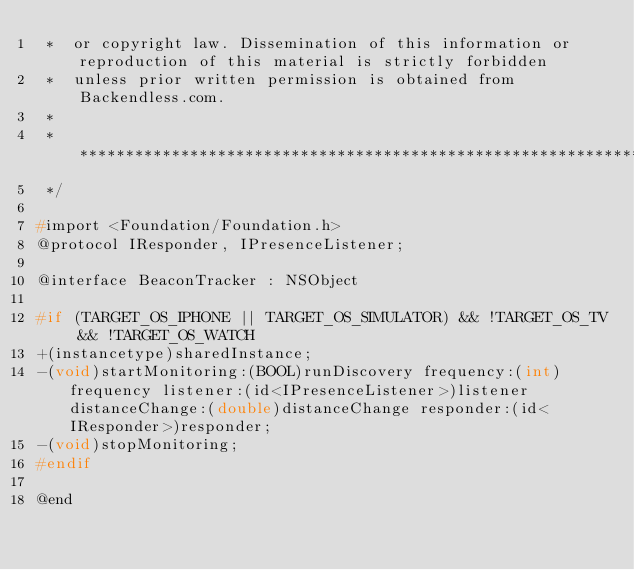<code> <loc_0><loc_0><loc_500><loc_500><_C_> *  or copyright law. Dissemination of this information or reproduction of this material is strictly forbidden
 *  unless prior written permission is obtained from Backendless.com.
 *
 *  ********************************************************************************************************************
 */

#import <Foundation/Foundation.h>
@protocol IResponder, IPresenceListener;

@interface BeaconTracker : NSObject

#if (TARGET_OS_IPHONE || TARGET_OS_SIMULATOR) && !TARGET_OS_TV && !TARGET_OS_WATCH
+(instancetype)sharedInstance;
-(void)startMonitoring:(BOOL)runDiscovery frequency:(int)frequency listener:(id<IPresenceListener>)listener distanceChange:(double)distanceChange responder:(id<IResponder>)responder;
-(void)stopMonitoring;
#endif

@end
</code> 